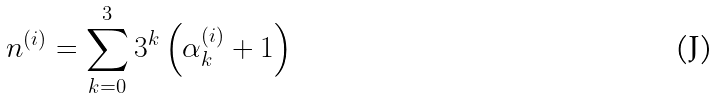<formula> <loc_0><loc_0><loc_500><loc_500>n ^ { ( i ) } = \sum _ { k = 0 } ^ { 3 } 3 ^ { k } \left ( \alpha _ { k } ^ { ( i ) } + 1 \right )</formula> 